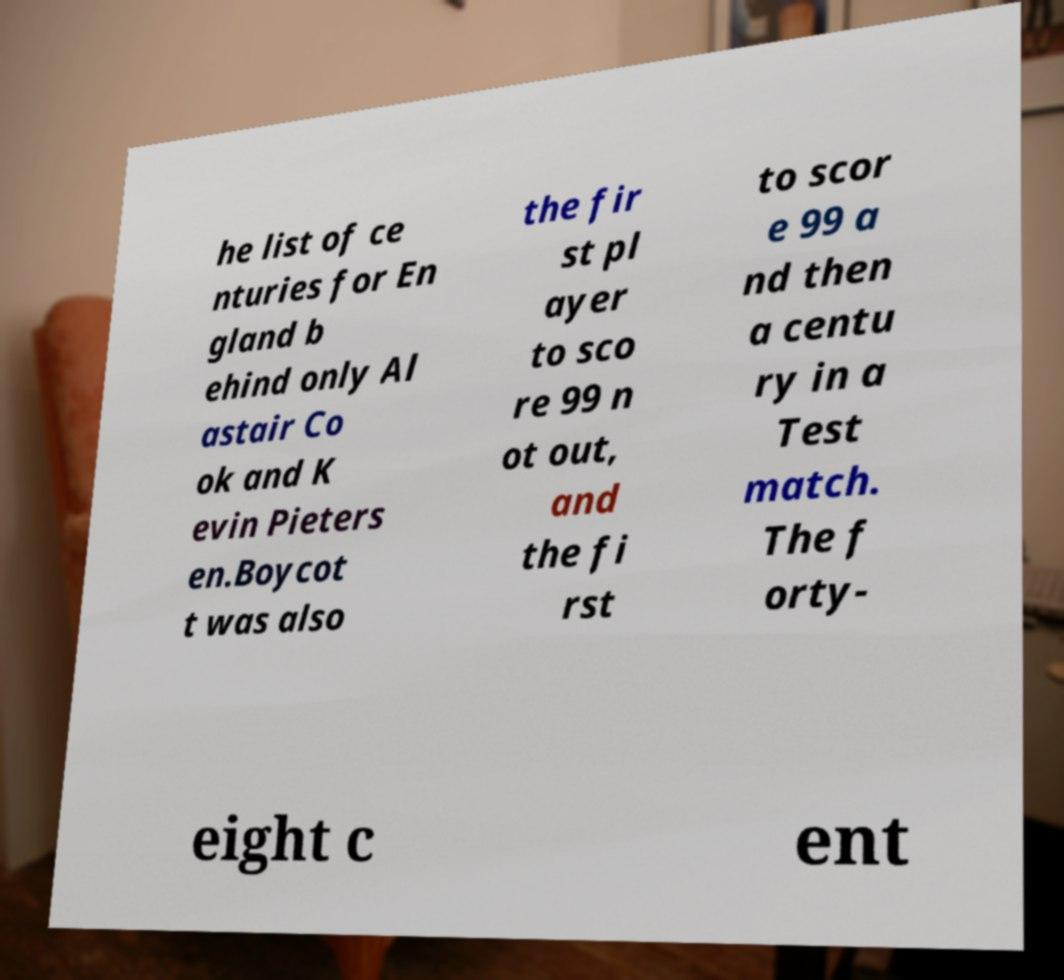Can you read and provide the text displayed in the image?This photo seems to have some interesting text. Can you extract and type it out for me? he list of ce nturies for En gland b ehind only Al astair Co ok and K evin Pieters en.Boycot t was also the fir st pl ayer to sco re 99 n ot out, and the fi rst to scor e 99 a nd then a centu ry in a Test match. The f orty- eight c ent 